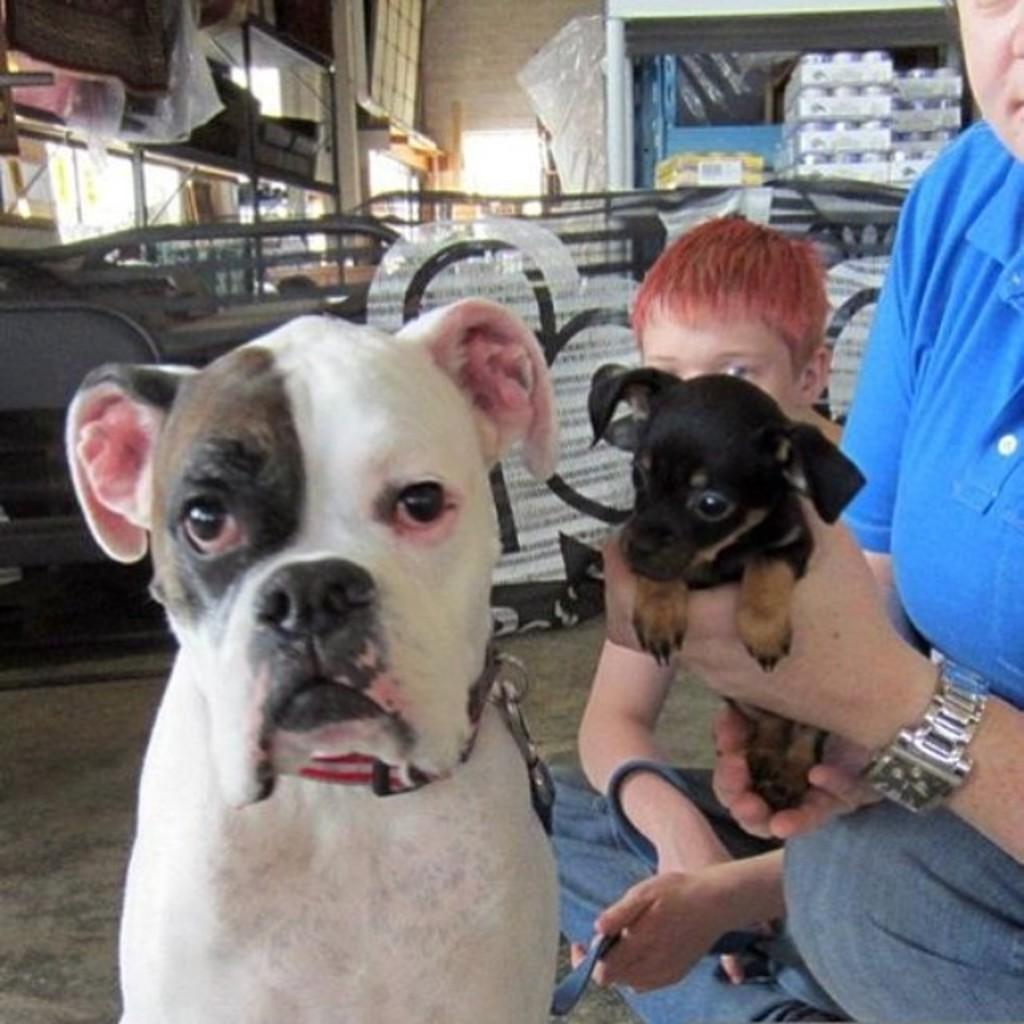What type of animal is in the image? There is a dog in the image. How many people are present in the image? There are two persons in the image. What is one of the persons holding? One of the persons is holding a small puppy. What historical event is being observed in the image? There is no historical event being observed in the image; it features a dog and two persons, one of whom is holding a small puppy. 